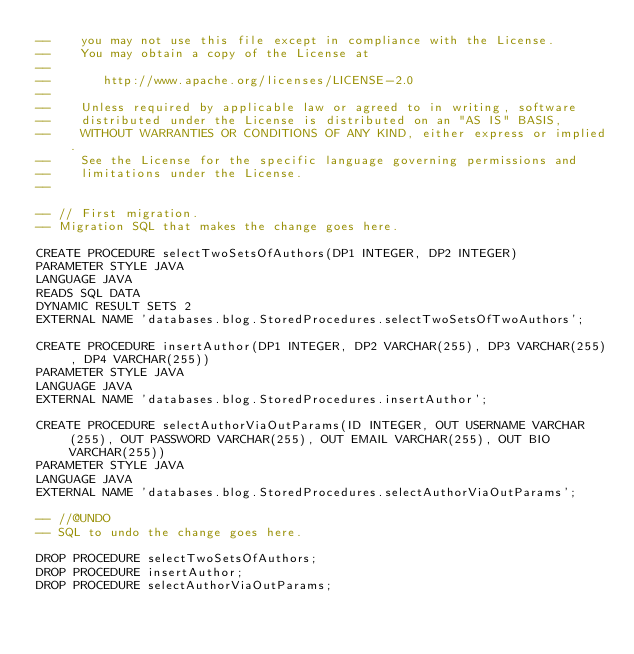<code> <loc_0><loc_0><loc_500><loc_500><_SQL_>--    you may not use this file except in compliance with the License.
--    You may obtain a copy of the License at
--
--       http://www.apache.org/licenses/LICENSE-2.0
--
--    Unless required by applicable law or agreed to in writing, software
--    distributed under the License is distributed on an "AS IS" BASIS,
--    WITHOUT WARRANTIES OR CONDITIONS OF ANY KIND, either express or implied.
--    See the License for the specific language governing permissions and
--    limitations under the License.
--

-- // First migration.
-- Migration SQL that makes the change goes here.

CREATE PROCEDURE selectTwoSetsOfAuthors(DP1 INTEGER, DP2 INTEGER)
PARAMETER STYLE JAVA
LANGUAGE JAVA
READS SQL DATA
DYNAMIC RESULT SETS 2
EXTERNAL NAME 'databases.blog.StoredProcedures.selectTwoSetsOfTwoAuthors';

CREATE PROCEDURE insertAuthor(DP1 INTEGER, DP2 VARCHAR(255), DP3 VARCHAR(255), DP4 VARCHAR(255))
PARAMETER STYLE JAVA
LANGUAGE JAVA
EXTERNAL NAME 'databases.blog.StoredProcedures.insertAuthor';

CREATE PROCEDURE selectAuthorViaOutParams(ID INTEGER, OUT USERNAME VARCHAR(255), OUT PASSWORD VARCHAR(255), OUT EMAIL VARCHAR(255), OUT BIO VARCHAR(255))
PARAMETER STYLE JAVA
LANGUAGE JAVA
EXTERNAL NAME 'databases.blog.StoredProcedures.selectAuthorViaOutParams';

-- //@UNDO
-- SQL to undo the change goes here.

DROP PROCEDURE selectTwoSetsOfAuthors;
DROP PROCEDURE insertAuthor;
DROP PROCEDURE selectAuthorViaOutParams;

</code> 